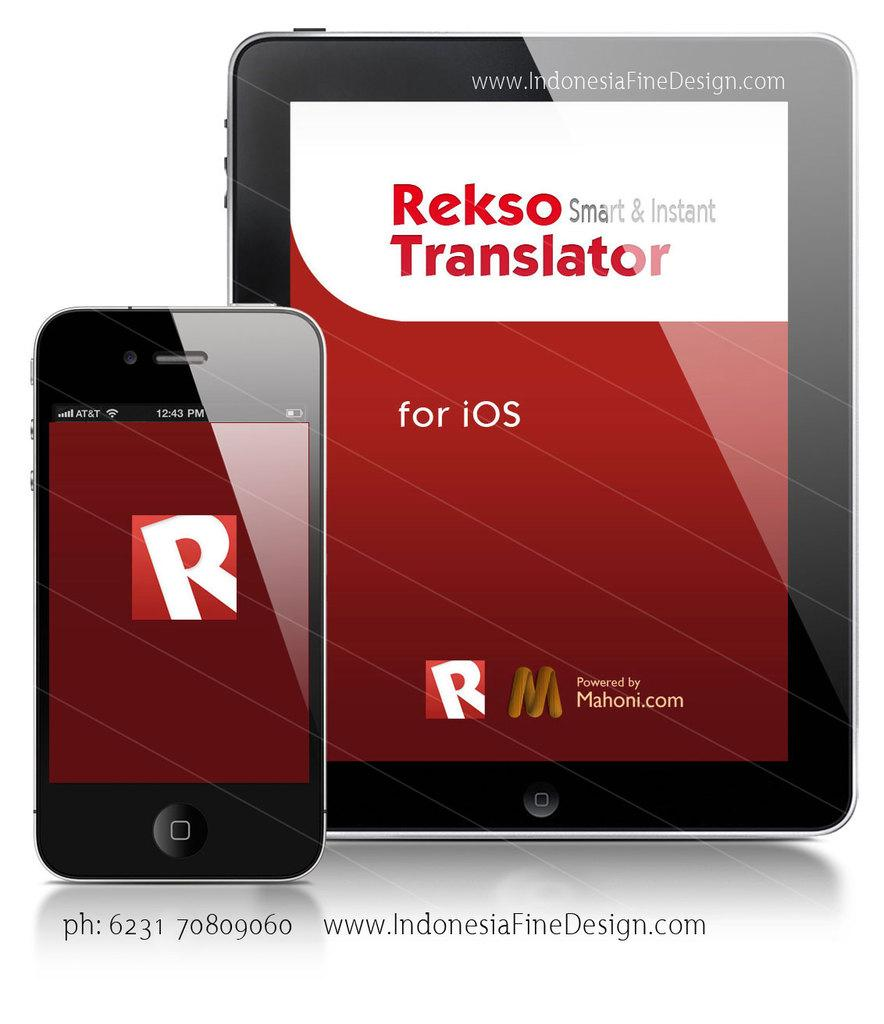<image>
Relay a brief, clear account of the picture shown. Rekso Smart and Instant Translator is shown on a smartphone and tablet. 